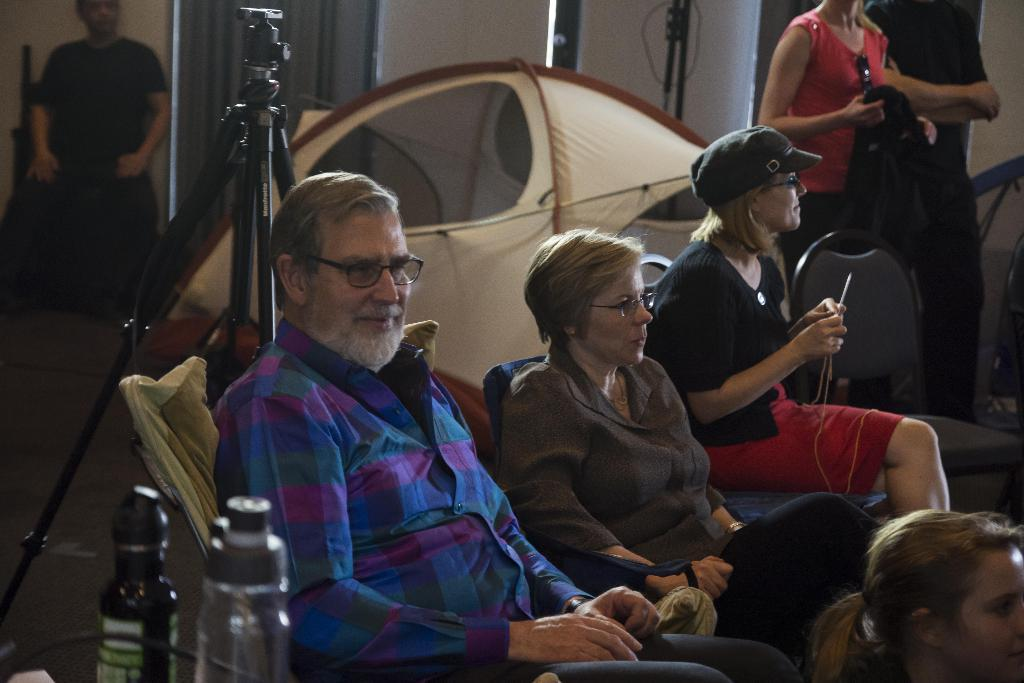Who or what can be seen in the image? There are people in the image. What objects are present in the image besides the people? There are two bottles in the image. What type of frame surrounds the people in the image? There is no frame surrounding the people in the image; it is a photograph or illustration without a frame. 